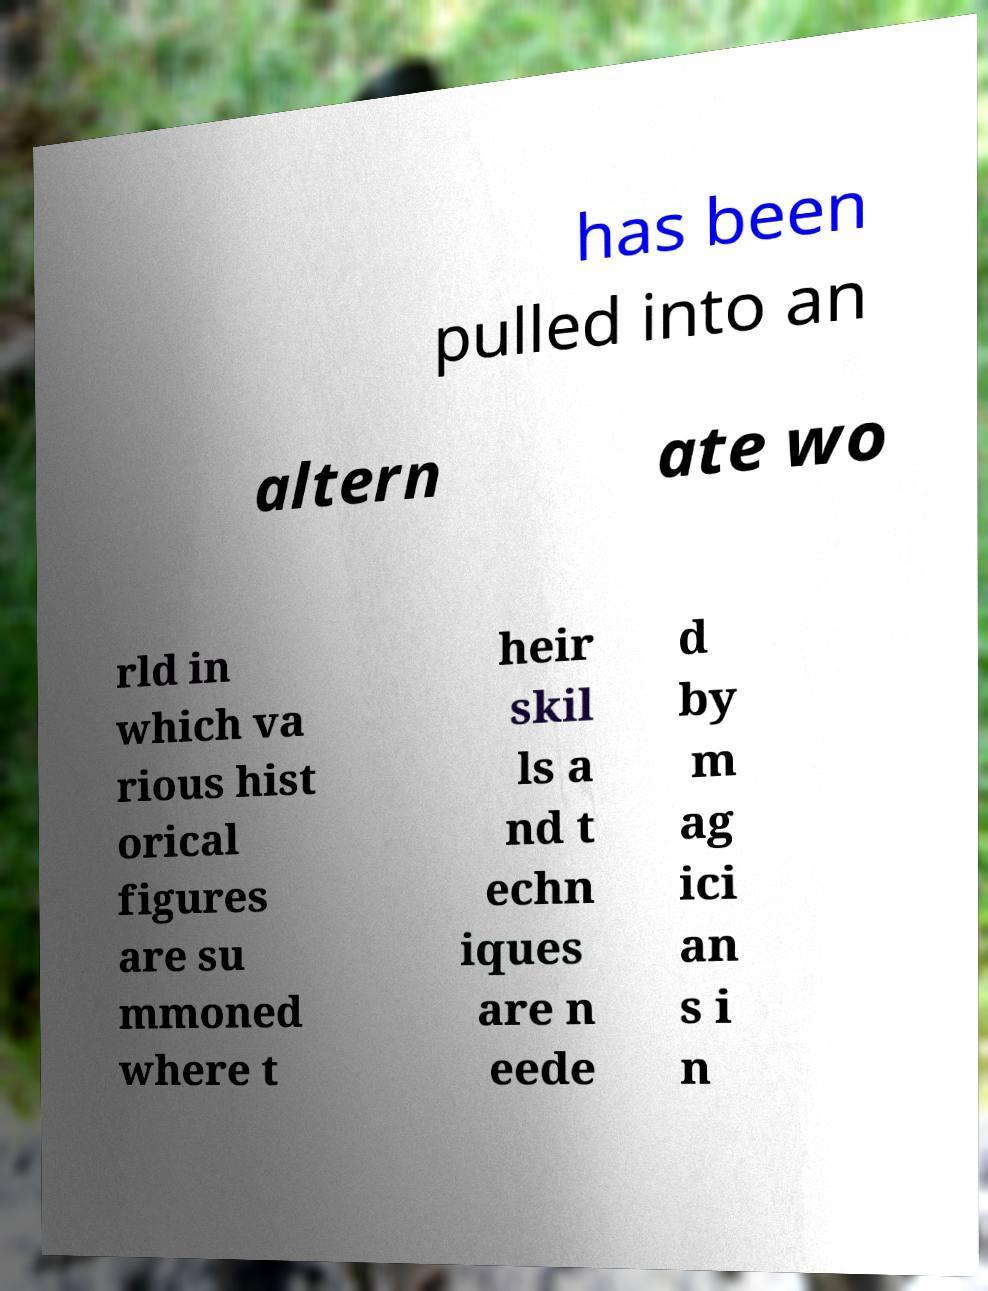There's text embedded in this image that I need extracted. Can you transcribe it verbatim? has been pulled into an altern ate wo rld in which va rious hist orical figures are su mmoned where t heir skil ls a nd t echn iques are n eede d by m ag ici an s i n 